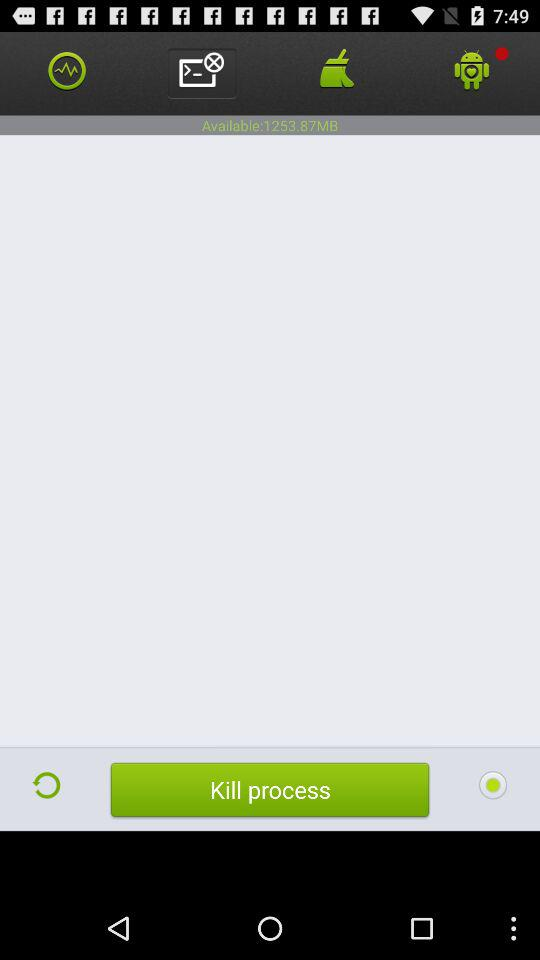What is the available space? The available space is 1253.87 MB. 